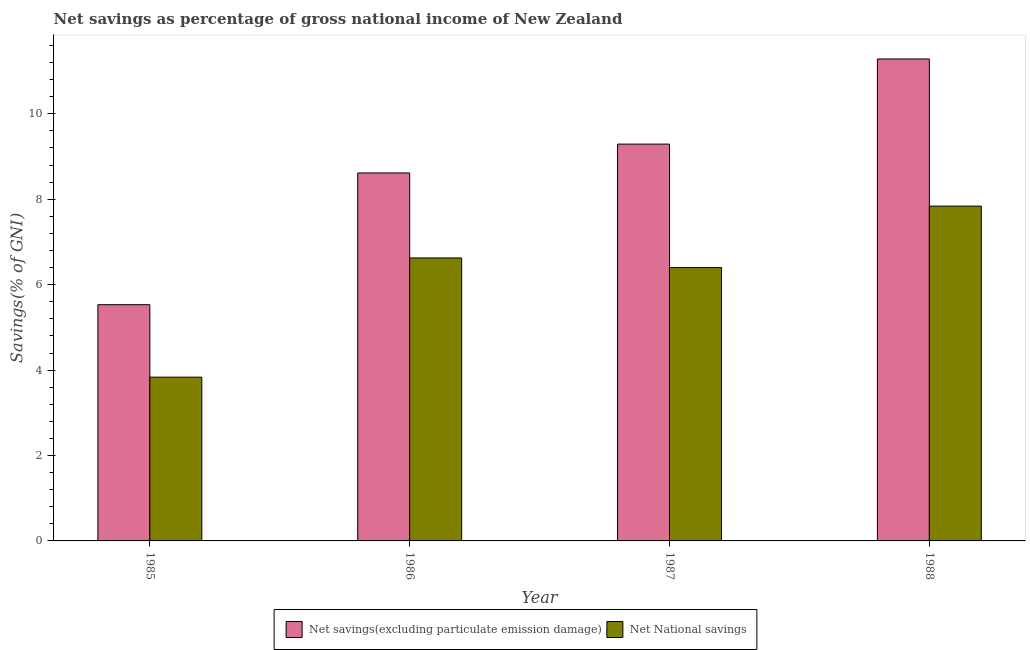Are the number of bars per tick equal to the number of legend labels?
Your response must be concise. Yes. Are the number of bars on each tick of the X-axis equal?
Your answer should be compact. Yes. What is the net savings(excluding particulate emission damage) in 1985?
Offer a very short reply. 5.53. Across all years, what is the maximum net national savings?
Give a very brief answer. 7.84. Across all years, what is the minimum net savings(excluding particulate emission damage)?
Your answer should be very brief. 5.53. What is the total net savings(excluding particulate emission damage) in the graph?
Make the answer very short. 34.72. What is the difference between the net savings(excluding particulate emission damage) in 1985 and that in 1988?
Give a very brief answer. -5.75. What is the difference between the net national savings in 1988 and the net savings(excluding particulate emission damage) in 1986?
Your response must be concise. 1.21. What is the average net national savings per year?
Give a very brief answer. 6.17. What is the ratio of the net savings(excluding particulate emission damage) in 1985 to that in 1988?
Provide a short and direct response. 0.49. Is the net savings(excluding particulate emission damage) in 1985 less than that in 1986?
Your response must be concise. Yes. What is the difference between the highest and the second highest net national savings?
Your response must be concise. 1.21. What is the difference between the highest and the lowest net national savings?
Give a very brief answer. 4. In how many years, is the net national savings greater than the average net national savings taken over all years?
Your answer should be very brief. 3. Is the sum of the net national savings in 1987 and 1988 greater than the maximum net savings(excluding particulate emission damage) across all years?
Your answer should be very brief. Yes. What does the 1st bar from the left in 1986 represents?
Provide a succinct answer. Net savings(excluding particulate emission damage). What does the 1st bar from the right in 1987 represents?
Keep it short and to the point. Net National savings. How many years are there in the graph?
Offer a very short reply. 4. Are the values on the major ticks of Y-axis written in scientific E-notation?
Give a very brief answer. No. Does the graph contain any zero values?
Make the answer very short. No. Where does the legend appear in the graph?
Give a very brief answer. Bottom center. How many legend labels are there?
Your answer should be very brief. 2. How are the legend labels stacked?
Your answer should be compact. Horizontal. What is the title of the graph?
Give a very brief answer. Net savings as percentage of gross national income of New Zealand. Does "Secondary" appear as one of the legend labels in the graph?
Give a very brief answer. No. What is the label or title of the Y-axis?
Give a very brief answer. Savings(% of GNI). What is the Savings(% of GNI) in Net savings(excluding particulate emission damage) in 1985?
Provide a short and direct response. 5.53. What is the Savings(% of GNI) in Net National savings in 1985?
Give a very brief answer. 3.83. What is the Savings(% of GNI) in Net savings(excluding particulate emission damage) in 1986?
Make the answer very short. 8.62. What is the Savings(% of GNI) in Net National savings in 1986?
Provide a short and direct response. 6.63. What is the Savings(% of GNI) of Net savings(excluding particulate emission damage) in 1987?
Your response must be concise. 9.29. What is the Savings(% of GNI) in Net National savings in 1987?
Ensure brevity in your answer.  6.4. What is the Savings(% of GNI) of Net savings(excluding particulate emission damage) in 1988?
Give a very brief answer. 11.28. What is the Savings(% of GNI) in Net National savings in 1988?
Make the answer very short. 7.84. Across all years, what is the maximum Savings(% of GNI) of Net savings(excluding particulate emission damage)?
Your response must be concise. 11.28. Across all years, what is the maximum Savings(% of GNI) in Net National savings?
Provide a succinct answer. 7.84. Across all years, what is the minimum Savings(% of GNI) of Net savings(excluding particulate emission damage)?
Provide a short and direct response. 5.53. Across all years, what is the minimum Savings(% of GNI) in Net National savings?
Make the answer very short. 3.83. What is the total Savings(% of GNI) in Net savings(excluding particulate emission damage) in the graph?
Offer a very short reply. 34.72. What is the total Savings(% of GNI) of Net National savings in the graph?
Provide a succinct answer. 24.7. What is the difference between the Savings(% of GNI) in Net savings(excluding particulate emission damage) in 1985 and that in 1986?
Provide a short and direct response. -3.08. What is the difference between the Savings(% of GNI) of Net National savings in 1985 and that in 1986?
Provide a succinct answer. -2.79. What is the difference between the Savings(% of GNI) of Net savings(excluding particulate emission damage) in 1985 and that in 1987?
Make the answer very short. -3.76. What is the difference between the Savings(% of GNI) of Net National savings in 1985 and that in 1987?
Ensure brevity in your answer.  -2.57. What is the difference between the Savings(% of GNI) in Net savings(excluding particulate emission damage) in 1985 and that in 1988?
Your answer should be compact. -5.75. What is the difference between the Savings(% of GNI) in Net National savings in 1985 and that in 1988?
Give a very brief answer. -4. What is the difference between the Savings(% of GNI) of Net savings(excluding particulate emission damage) in 1986 and that in 1987?
Your answer should be compact. -0.68. What is the difference between the Savings(% of GNI) of Net National savings in 1986 and that in 1987?
Your answer should be compact. 0.23. What is the difference between the Savings(% of GNI) in Net savings(excluding particulate emission damage) in 1986 and that in 1988?
Your answer should be very brief. -2.67. What is the difference between the Savings(% of GNI) of Net National savings in 1986 and that in 1988?
Keep it short and to the point. -1.21. What is the difference between the Savings(% of GNI) of Net savings(excluding particulate emission damage) in 1987 and that in 1988?
Your answer should be compact. -1.99. What is the difference between the Savings(% of GNI) in Net National savings in 1987 and that in 1988?
Provide a succinct answer. -1.44. What is the difference between the Savings(% of GNI) in Net savings(excluding particulate emission damage) in 1985 and the Savings(% of GNI) in Net National savings in 1986?
Offer a very short reply. -1.09. What is the difference between the Savings(% of GNI) of Net savings(excluding particulate emission damage) in 1985 and the Savings(% of GNI) of Net National savings in 1987?
Make the answer very short. -0.87. What is the difference between the Savings(% of GNI) in Net savings(excluding particulate emission damage) in 1985 and the Savings(% of GNI) in Net National savings in 1988?
Your answer should be very brief. -2.31. What is the difference between the Savings(% of GNI) of Net savings(excluding particulate emission damage) in 1986 and the Savings(% of GNI) of Net National savings in 1987?
Offer a terse response. 2.22. What is the difference between the Savings(% of GNI) in Net savings(excluding particulate emission damage) in 1986 and the Savings(% of GNI) in Net National savings in 1988?
Provide a succinct answer. 0.78. What is the difference between the Savings(% of GNI) in Net savings(excluding particulate emission damage) in 1987 and the Savings(% of GNI) in Net National savings in 1988?
Ensure brevity in your answer.  1.45. What is the average Savings(% of GNI) of Net savings(excluding particulate emission damage) per year?
Your answer should be compact. 8.68. What is the average Savings(% of GNI) in Net National savings per year?
Offer a very short reply. 6.17. In the year 1985, what is the difference between the Savings(% of GNI) in Net savings(excluding particulate emission damage) and Savings(% of GNI) in Net National savings?
Provide a short and direct response. 1.7. In the year 1986, what is the difference between the Savings(% of GNI) in Net savings(excluding particulate emission damage) and Savings(% of GNI) in Net National savings?
Provide a short and direct response. 1.99. In the year 1987, what is the difference between the Savings(% of GNI) in Net savings(excluding particulate emission damage) and Savings(% of GNI) in Net National savings?
Your answer should be compact. 2.89. In the year 1988, what is the difference between the Savings(% of GNI) of Net savings(excluding particulate emission damage) and Savings(% of GNI) of Net National savings?
Your response must be concise. 3.45. What is the ratio of the Savings(% of GNI) in Net savings(excluding particulate emission damage) in 1985 to that in 1986?
Provide a short and direct response. 0.64. What is the ratio of the Savings(% of GNI) in Net National savings in 1985 to that in 1986?
Offer a terse response. 0.58. What is the ratio of the Savings(% of GNI) in Net savings(excluding particulate emission damage) in 1985 to that in 1987?
Give a very brief answer. 0.6. What is the ratio of the Savings(% of GNI) of Net National savings in 1985 to that in 1987?
Your response must be concise. 0.6. What is the ratio of the Savings(% of GNI) in Net savings(excluding particulate emission damage) in 1985 to that in 1988?
Ensure brevity in your answer.  0.49. What is the ratio of the Savings(% of GNI) in Net National savings in 1985 to that in 1988?
Provide a short and direct response. 0.49. What is the ratio of the Savings(% of GNI) in Net savings(excluding particulate emission damage) in 1986 to that in 1987?
Your response must be concise. 0.93. What is the ratio of the Savings(% of GNI) in Net National savings in 1986 to that in 1987?
Make the answer very short. 1.04. What is the ratio of the Savings(% of GNI) of Net savings(excluding particulate emission damage) in 1986 to that in 1988?
Ensure brevity in your answer.  0.76. What is the ratio of the Savings(% of GNI) of Net National savings in 1986 to that in 1988?
Your answer should be very brief. 0.85. What is the ratio of the Savings(% of GNI) in Net savings(excluding particulate emission damage) in 1987 to that in 1988?
Make the answer very short. 0.82. What is the ratio of the Savings(% of GNI) of Net National savings in 1987 to that in 1988?
Your answer should be very brief. 0.82. What is the difference between the highest and the second highest Savings(% of GNI) in Net savings(excluding particulate emission damage)?
Provide a short and direct response. 1.99. What is the difference between the highest and the second highest Savings(% of GNI) in Net National savings?
Your answer should be compact. 1.21. What is the difference between the highest and the lowest Savings(% of GNI) in Net savings(excluding particulate emission damage)?
Provide a succinct answer. 5.75. What is the difference between the highest and the lowest Savings(% of GNI) in Net National savings?
Give a very brief answer. 4. 